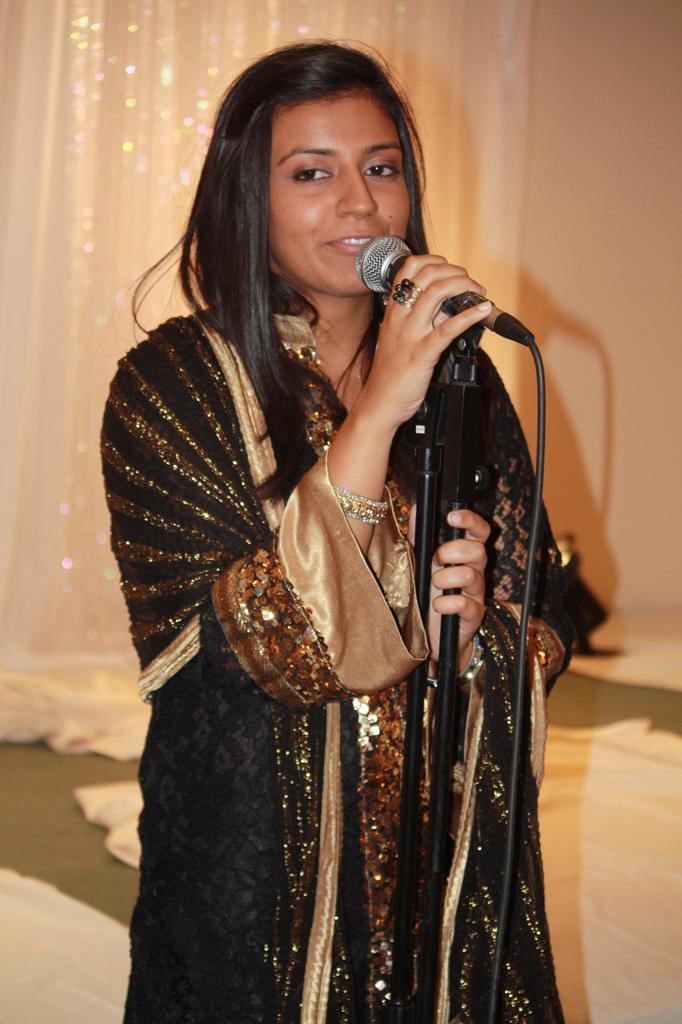How would you summarize this image in a sentence or two? In this picture we can see a woman, she is holding a mic and in the background we can see a wall, curtain, clothes. 